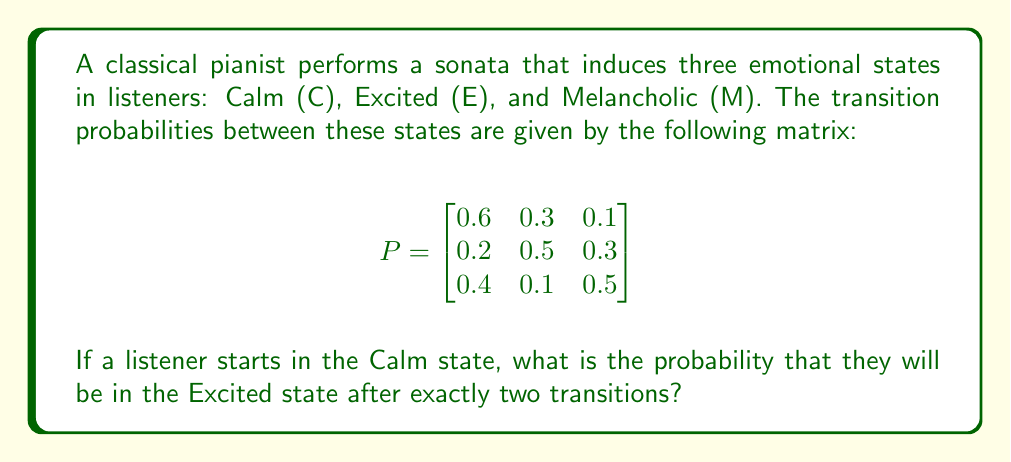Teach me how to tackle this problem. To solve this problem, we need to use the Chapman-Kolmogorov equations and matrix multiplication. Let's break it down step-by-step:

1) The given transition probability matrix P represents one-step transitions.

2) To find the probability of being in a particular state after two transitions, we need to calculate $P^2$.

3) We can compute $P^2$ as follows:

   $$P^2 = P \times P = \begin{bmatrix}
   0.6 & 0.3 & 0.1 \\
   0.2 & 0.5 & 0.3 \\
   0.4 & 0.1 & 0.5
   \end{bmatrix} \times \begin{bmatrix}
   0.6 & 0.3 & 0.1 \\
   0.2 & 0.5 & 0.3 \\
   0.4 & 0.1 & 0.5
   \end{bmatrix}$$

4) Performing the matrix multiplication:

   $$P^2 = \begin{bmatrix}
   0.44 & 0.33 & 0.23 \\
   0.34 & 0.35 & 0.31 \\
   0.46 & 0.23 & 0.31
   \end{bmatrix}$$

5) The listener starts in the Calm state (C), which corresponds to the first row of $P^2$.

6) The probability of being in the Excited state (E) after two transitions is the element in the first row, second column of $P^2$, which is 0.33.

Therefore, the probability that a listener starting in the Calm state will be in the Excited state after exactly two transitions is 0.33 or 33%.
Answer: 0.33 